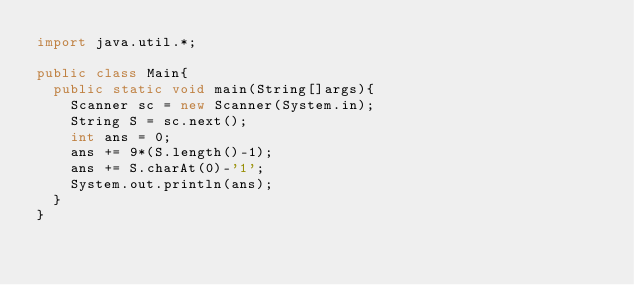Convert code to text. <code><loc_0><loc_0><loc_500><loc_500><_Java_>import java.util.*;

public class Main{
  public static void main(String[]args){
    Scanner sc = new Scanner(System.in);
    String S = sc.next();
    int ans = 0;
    ans += 9*(S.length()-1);
    ans += S.charAt(0)-'1';
    System.out.println(ans);
  }
}</code> 